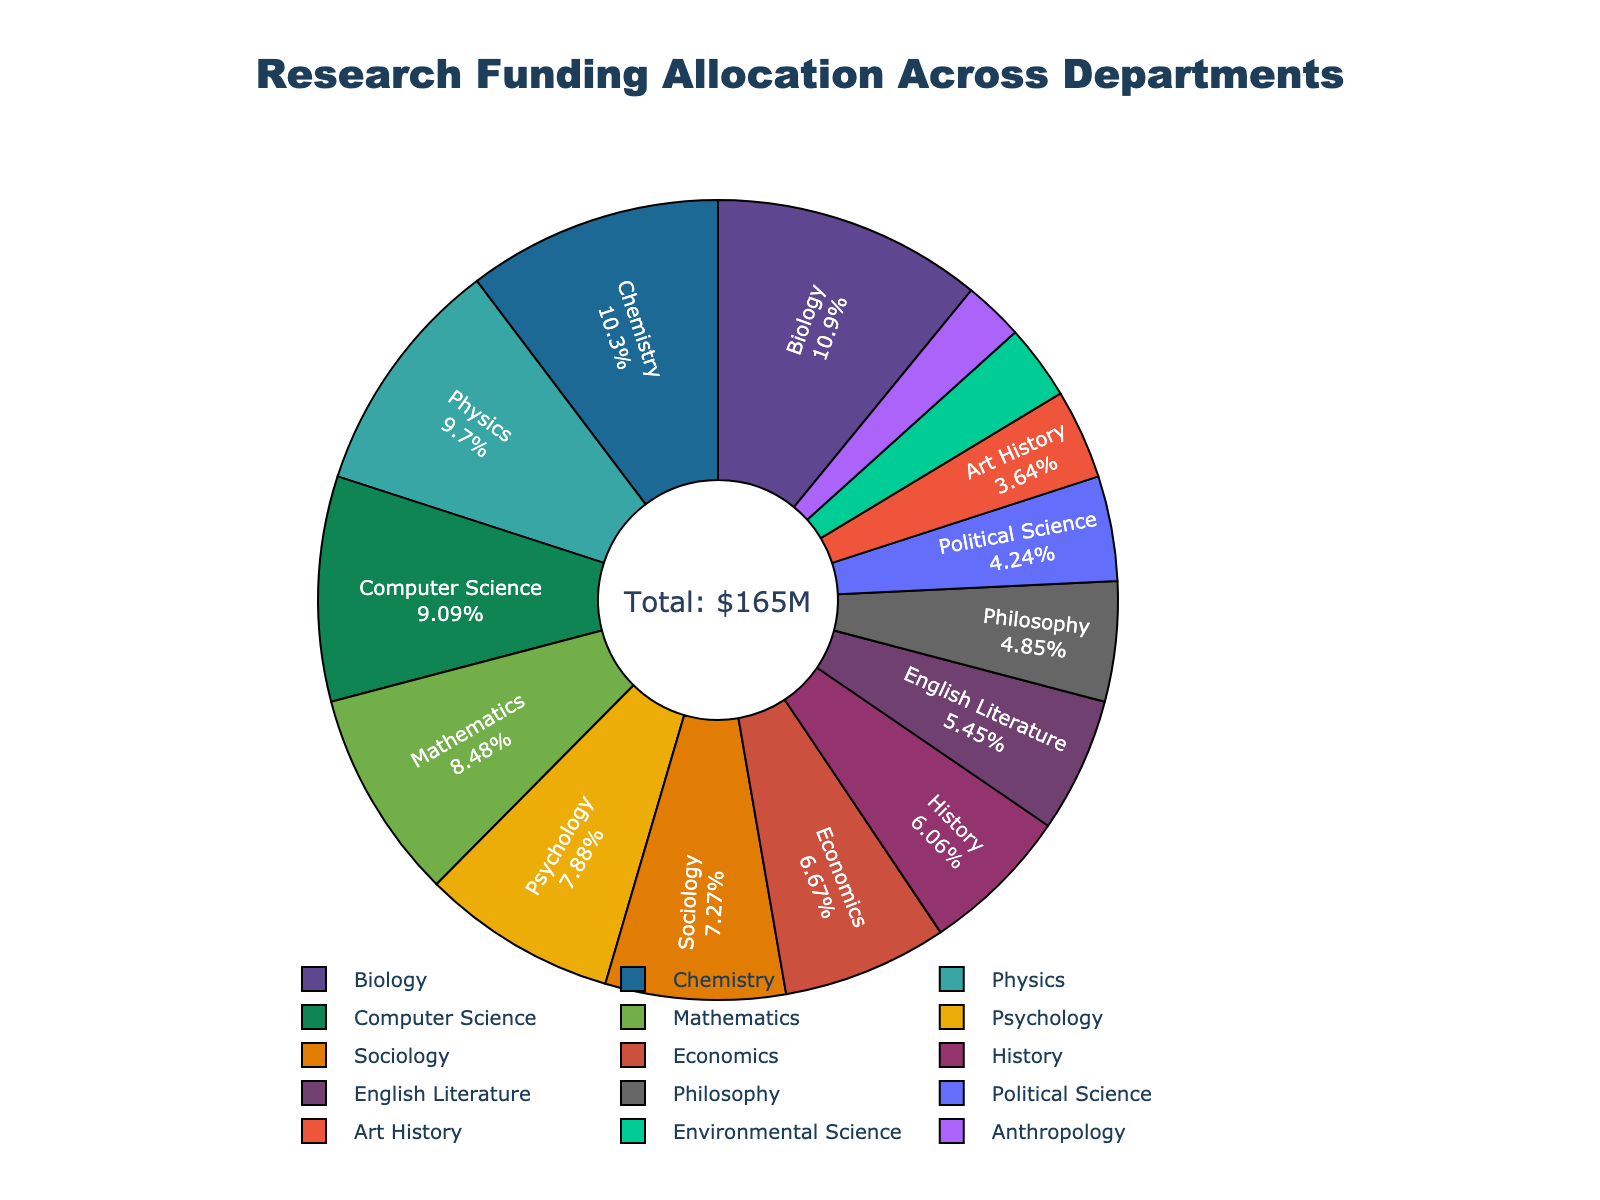Which department receives the most research funding? The department with the largest slice and highest percentage in the pie chart will show the highest funding allocation. Biology has the largest slice.
Answer: Biology How does the funding for Chemistry compare to Computer Science? Locate both Chemistry and Computer Science in the pie chart. Chemistry has 17% and Computer Science has 15%. Chemistry's funding is slightly higher than Computer Science.
Answer: Chemistry has a higher allocation What's the combined funding allocation for History and English Literature? Identify the funding percentages of History (10%) and English Literature (9%) and sum them. 10% + 9% = 19%.
Answer: 19% Between Art History and Environmental Science, which department has a smaller funding allocation? Compare the slices for Art History (6%) and Environmental Science (5%). Environmental Science has a smaller allocation.
Answer: Environmental Science What is the total funding allocation for the Mathematics and Sociology departments? Sum the percentages allocated to Mathematics (14%) and Sociology (12%). 14% + 12% = 26%.
Answer: 26% What percentage of the total funding does Philosophy receive? Find Philosophy in the pie chart. Its allocation is 8%.
Answer: 8% Is the funding allocated to Psychology more than that to Political Science? Compare the slices for Psychology (13%) and Political Science (7%). Psychology has a larger allocation.
Answer: Yes How does the funding for Anthropology compare to Environmental Science? Identify and compare the slices for Anthropology (4%) and Environmental Science (5%). Environmental Science has a larger funding allocation.
Answer: Environmental Science has a higher allocation What’s the difference in funding allocation between Economics and Sociology? Find the funding percentages for Economics (11%) and Sociology (12%), then subtract the smaller from the larger. 12% - 11% = 1%.
Answer: 1% What portion of the total funding is allocated to the top three departments? Identify the top three departments by slice size (Biology 18%, Chemistry 17%, and Physics 16%) and sum their percentages. 18% + 17% + 16% = 51%.
Answer: 51% 